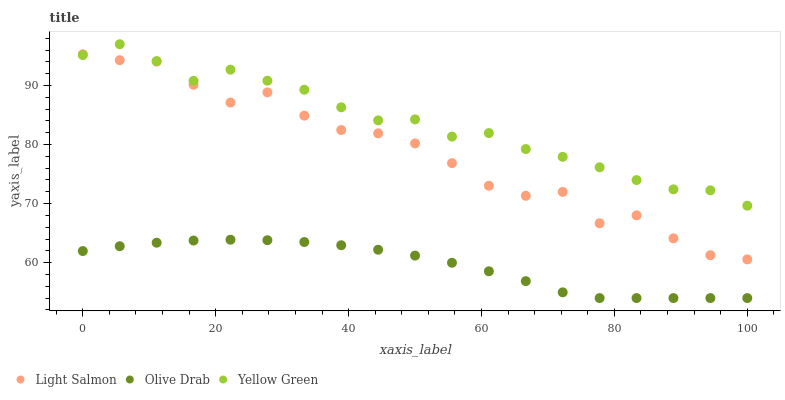Does Olive Drab have the minimum area under the curve?
Answer yes or no. Yes. Does Yellow Green have the maximum area under the curve?
Answer yes or no. Yes. Does Yellow Green have the minimum area under the curve?
Answer yes or no. No. Does Olive Drab have the maximum area under the curve?
Answer yes or no. No. Is Olive Drab the smoothest?
Answer yes or no. Yes. Is Light Salmon the roughest?
Answer yes or no. Yes. Is Yellow Green the smoothest?
Answer yes or no. No. Is Yellow Green the roughest?
Answer yes or no. No. Does Olive Drab have the lowest value?
Answer yes or no. Yes. Does Yellow Green have the lowest value?
Answer yes or no. No. Does Yellow Green have the highest value?
Answer yes or no. Yes. Does Olive Drab have the highest value?
Answer yes or no. No. Is Olive Drab less than Yellow Green?
Answer yes or no. Yes. Is Yellow Green greater than Olive Drab?
Answer yes or no. Yes. Does Light Salmon intersect Yellow Green?
Answer yes or no. Yes. Is Light Salmon less than Yellow Green?
Answer yes or no. No. Is Light Salmon greater than Yellow Green?
Answer yes or no. No. Does Olive Drab intersect Yellow Green?
Answer yes or no. No. 